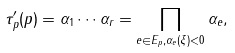<formula> <loc_0><loc_0><loc_500><loc_500>\tau _ { p } ^ { \prime } ( p ) = \alpha _ { 1 } \cdots \alpha _ { r } = \prod _ { e \in E _ { p } , \alpha _ { e } ( \xi ) < 0 } \alpha _ { e } ,</formula> 